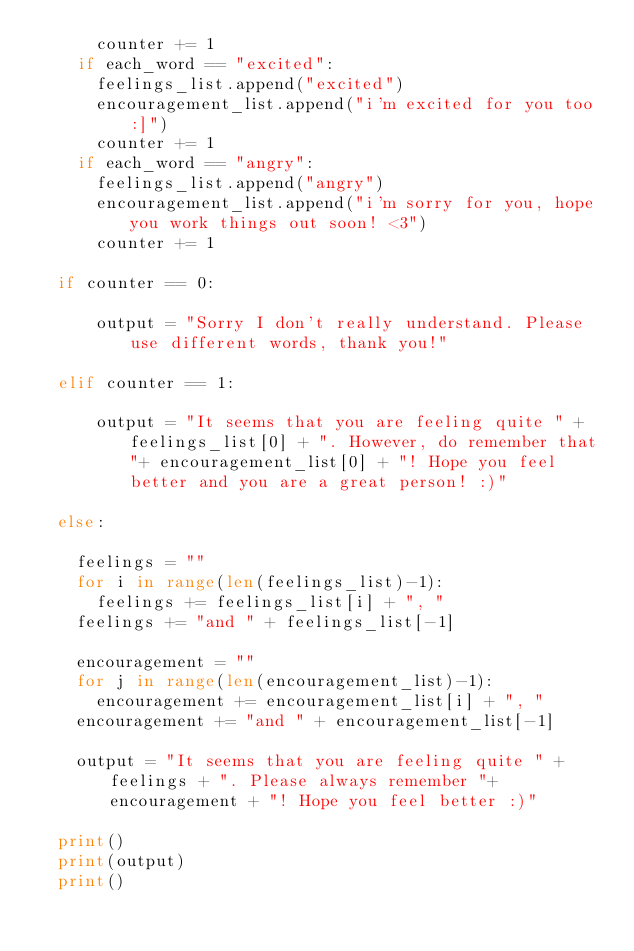Convert code to text. <code><loc_0><loc_0><loc_500><loc_500><_Python_>      counter += 1
    if each_word == "excited":
      feelings_list.append("excited")
      encouragement_list.append("i'm excited for you too :]")
      counter += 1
    if each_word == "angry":
      feelings_list.append("angry")
      encouragement_list.append("i'm sorry for you, hope you work things out soon! <3")
      counter += 1

  if counter == 0:
    
      output = "Sorry I don't really understand. Please use different words, thank you!"

  elif counter == 1:
    
      output = "It seems that you are feeling quite " + feelings_list[0] + ". However, do remember that "+ encouragement_list[0] + "! Hope you feel better and you are a great person! :)"  

  else:

    feelings = ""    
    for i in range(len(feelings_list)-1):
      feelings += feelings_list[i] + ", "
    feelings += "and " + feelings_list[-1]
    
    encouragement = ""    
    for j in range(len(encouragement_list)-1):
      encouragement += encouragement_list[i] + ", "
    encouragement += "and " + encouragement_list[-1]

    output = "It seems that you are feeling quite " + feelings + ". Please always remember "+ encouragement + "! Hope you feel better :)"

  print()
  print(output)
  print()
</code> 